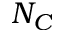Convert formula to latex. <formula><loc_0><loc_0><loc_500><loc_500>N _ { C }</formula> 